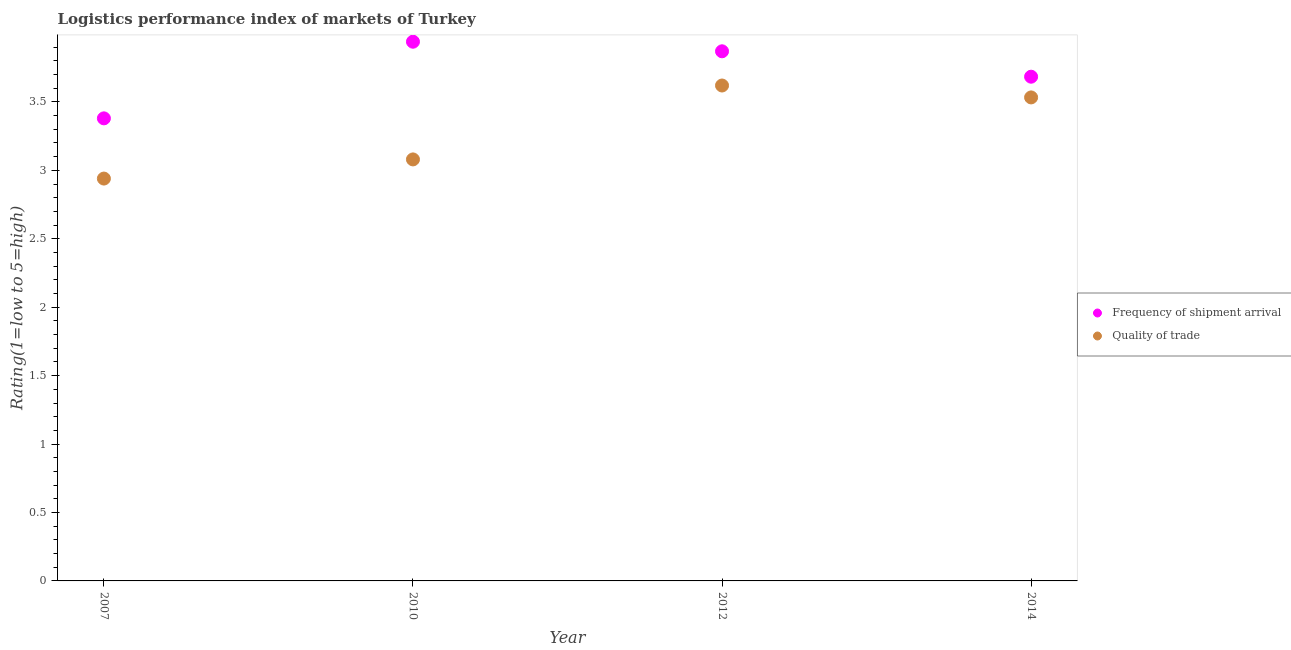How many different coloured dotlines are there?
Provide a short and direct response. 2. Is the number of dotlines equal to the number of legend labels?
Ensure brevity in your answer.  Yes. What is the lpi of frequency of shipment arrival in 2012?
Offer a very short reply. 3.87. Across all years, what is the maximum lpi of frequency of shipment arrival?
Keep it short and to the point. 3.94. Across all years, what is the minimum lpi of frequency of shipment arrival?
Provide a short and direct response. 3.38. In which year was the lpi quality of trade maximum?
Make the answer very short. 2012. In which year was the lpi of frequency of shipment arrival minimum?
Provide a short and direct response. 2007. What is the total lpi of frequency of shipment arrival in the graph?
Your answer should be compact. 14.87. What is the difference between the lpi quality of trade in 2007 and that in 2014?
Offer a very short reply. -0.59. What is the difference between the lpi quality of trade in 2007 and the lpi of frequency of shipment arrival in 2012?
Keep it short and to the point. -0.93. What is the average lpi quality of trade per year?
Your answer should be compact. 3.29. In the year 2012, what is the difference between the lpi quality of trade and lpi of frequency of shipment arrival?
Your answer should be compact. -0.25. What is the ratio of the lpi quality of trade in 2007 to that in 2010?
Provide a short and direct response. 0.95. Is the lpi of frequency of shipment arrival in 2007 less than that in 2014?
Your answer should be compact. Yes. Is the difference between the lpi of frequency of shipment arrival in 2010 and 2014 greater than the difference between the lpi quality of trade in 2010 and 2014?
Offer a very short reply. Yes. What is the difference between the highest and the second highest lpi quality of trade?
Your response must be concise. 0.09. What is the difference between the highest and the lowest lpi quality of trade?
Your response must be concise. 0.68. In how many years, is the lpi of frequency of shipment arrival greater than the average lpi of frequency of shipment arrival taken over all years?
Offer a very short reply. 2. Is the sum of the lpi of frequency of shipment arrival in 2010 and 2012 greater than the maximum lpi quality of trade across all years?
Give a very brief answer. Yes. Is the lpi of frequency of shipment arrival strictly greater than the lpi quality of trade over the years?
Your answer should be compact. Yes. How many dotlines are there?
Ensure brevity in your answer.  2. How many years are there in the graph?
Offer a very short reply. 4. What is the difference between two consecutive major ticks on the Y-axis?
Your answer should be compact. 0.5. Does the graph contain any zero values?
Provide a short and direct response. No. How are the legend labels stacked?
Give a very brief answer. Vertical. What is the title of the graph?
Your answer should be compact. Logistics performance index of markets of Turkey. What is the label or title of the X-axis?
Provide a short and direct response. Year. What is the label or title of the Y-axis?
Give a very brief answer. Rating(1=low to 5=high). What is the Rating(1=low to 5=high) of Frequency of shipment arrival in 2007?
Offer a terse response. 3.38. What is the Rating(1=low to 5=high) of Quality of trade in 2007?
Offer a very short reply. 2.94. What is the Rating(1=low to 5=high) of Frequency of shipment arrival in 2010?
Offer a very short reply. 3.94. What is the Rating(1=low to 5=high) of Quality of trade in 2010?
Ensure brevity in your answer.  3.08. What is the Rating(1=low to 5=high) in Frequency of shipment arrival in 2012?
Make the answer very short. 3.87. What is the Rating(1=low to 5=high) of Quality of trade in 2012?
Your response must be concise. 3.62. What is the Rating(1=low to 5=high) in Frequency of shipment arrival in 2014?
Offer a terse response. 3.68. What is the Rating(1=low to 5=high) of Quality of trade in 2014?
Your response must be concise. 3.53. Across all years, what is the maximum Rating(1=low to 5=high) in Frequency of shipment arrival?
Provide a succinct answer. 3.94. Across all years, what is the maximum Rating(1=low to 5=high) of Quality of trade?
Make the answer very short. 3.62. Across all years, what is the minimum Rating(1=low to 5=high) of Frequency of shipment arrival?
Your response must be concise. 3.38. Across all years, what is the minimum Rating(1=low to 5=high) of Quality of trade?
Provide a succinct answer. 2.94. What is the total Rating(1=low to 5=high) of Frequency of shipment arrival in the graph?
Give a very brief answer. 14.87. What is the total Rating(1=low to 5=high) in Quality of trade in the graph?
Offer a terse response. 13.17. What is the difference between the Rating(1=low to 5=high) in Frequency of shipment arrival in 2007 and that in 2010?
Give a very brief answer. -0.56. What is the difference between the Rating(1=low to 5=high) of Quality of trade in 2007 and that in 2010?
Make the answer very short. -0.14. What is the difference between the Rating(1=low to 5=high) in Frequency of shipment arrival in 2007 and that in 2012?
Ensure brevity in your answer.  -0.49. What is the difference between the Rating(1=low to 5=high) in Quality of trade in 2007 and that in 2012?
Your answer should be compact. -0.68. What is the difference between the Rating(1=low to 5=high) of Frequency of shipment arrival in 2007 and that in 2014?
Provide a short and direct response. -0.3. What is the difference between the Rating(1=low to 5=high) in Quality of trade in 2007 and that in 2014?
Your answer should be very brief. -0.59. What is the difference between the Rating(1=low to 5=high) in Frequency of shipment arrival in 2010 and that in 2012?
Your answer should be very brief. 0.07. What is the difference between the Rating(1=low to 5=high) of Quality of trade in 2010 and that in 2012?
Provide a short and direct response. -0.54. What is the difference between the Rating(1=low to 5=high) of Frequency of shipment arrival in 2010 and that in 2014?
Ensure brevity in your answer.  0.26. What is the difference between the Rating(1=low to 5=high) in Quality of trade in 2010 and that in 2014?
Ensure brevity in your answer.  -0.45. What is the difference between the Rating(1=low to 5=high) of Frequency of shipment arrival in 2012 and that in 2014?
Offer a terse response. 0.19. What is the difference between the Rating(1=low to 5=high) of Quality of trade in 2012 and that in 2014?
Your answer should be very brief. 0.09. What is the difference between the Rating(1=low to 5=high) in Frequency of shipment arrival in 2007 and the Rating(1=low to 5=high) in Quality of trade in 2012?
Provide a short and direct response. -0.24. What is the difference between the Rating(1=low to 5=high) in Frequency of shipment arrival in 2007 and the Rating(1=low to 5=high) in Quality of trade in 2014?
Your response must be concise. -0.15. What is the difference between the Rating(1=low to 5=high) of Frequency of shipment arrival in 2010 and the Rating(1=low to 5=high) of Quality of trade in 2012?
Your response must be concise. 0.32. What is the difference between the Rating(1=low to 5=high) in Frequency of shipment arrival in 2010 and the Rating(1=low to 5=high) in Quality of trade in 2014?
Ensure brevity in your answer.  0.41. What is the difference between the Rating(1=low to 5=high) in Frequency of shipment arrival in 2012 and the Rating(1=low to 5=high) in Quality of trade in 2014?
Keep it short and to the point. 0.34. What is the average Rating(1=low to 5=high) in Frequency of shipment arrival per year?
Give a very brief answer. 3.72. What is the average Rating(1=low to 5=high) of Quality of trade per year?
Keep it short and to the point. 3.29. In the year 2007, what is the difference between the Rating(1=low to 5=high) in Frequency of shipment arrival and Rating(1=low to 5=high) in Quality of trade?
Your answer should be very brief. 0.44. In the year 2010, what is the difference between the Rating(1=low to 5=high) in Frequency of shipment arrival and Rating(1=low to 5=high) in Quality of trade?
Make the answer very short. 0.86. In the year 2014, what is the difference between the Rating(1=low to 5=high) of Frequency of shipment arrival and Rating(1=low to 5=high) of Quality of trade?
Your response must be concise. 0.15. What is the ratio of the Rating(1=low to 5=high) in Frequency of shipment arrival in 2007 to that in 2010?
Make the answer very short. 0.86. What is the ratio of the Rating(1=low to 5=high) of Quality of trade in 2007 to that in 2010?
Make the answer very short. 0.95. What is the ratio of the Rating(1=low to 5=high) of Frequency of shipment arrival in 2007 to that in 2012?
Offer a very short reply. 0.87. What is the ratio of the Rating(1=low to 5=high) of Quality of trade in 2007 to that in 2012?
Your answer should be very brief. 0.81. What is the ratio of the Rating(1=low to 5=high) of Frequency of shipment arrival in 2007 to that in 2014?
Offer a very short reply. 0.92. What is the ratio of the Rating(1=low to 5=high) in Quality of trade in 2007 to that in 2014?
Offer a very short reply. 0.83. What is the ratio of the Rating(1=low to 5=high) of Frequency of shipment arrival in 2010 to that in 2012?
Offer a terse response. 1.02. What is the ratio of the Rating(1=low to 5=high) in Quality of trade in 2010 to that in 2012?
Provide a short and direct response. 0.85. What is the ratio of the Rating(1=low to 5=high) of Frequency of shipment arrival in 2010 to that in 2014?
Provide a succinct answer. 1.07. What is the ratio of the Rating(1=low to 5=high) in Quality of trade in 2010 to that in 2014?
Make the answer very short. 0.87. What is the ratio of the Rating(1=low to 5=high) in Frequency of shipment arrival in 2012 to that in 2014?
Provide a short and direct response. 1.05. What is the ratio of the Rating(1=low to 5=high) in Quality of trade in 2012 to that in 2014?
Provide a short and direct response. 1.02. What is the difference between the highest and the second highest Rating(1=low to 5=high) of Frequency of shipment arrival?
Your answer should be compact. 0.07. What is the difference between the highest and the second highest Rating(1=low to 5=high) of Quality of trade?
Your answer should be compact. 0.09. What is the difference between the highest and the lowest Rating(1=low to 5=high) of Frequency of shipment arrival?
Your answer should be compact. 0.56. What is the difference between the highest and the lowest Rating(1=low to 5=high) of Quality of trade?
Your response must be concise. 0.68. 